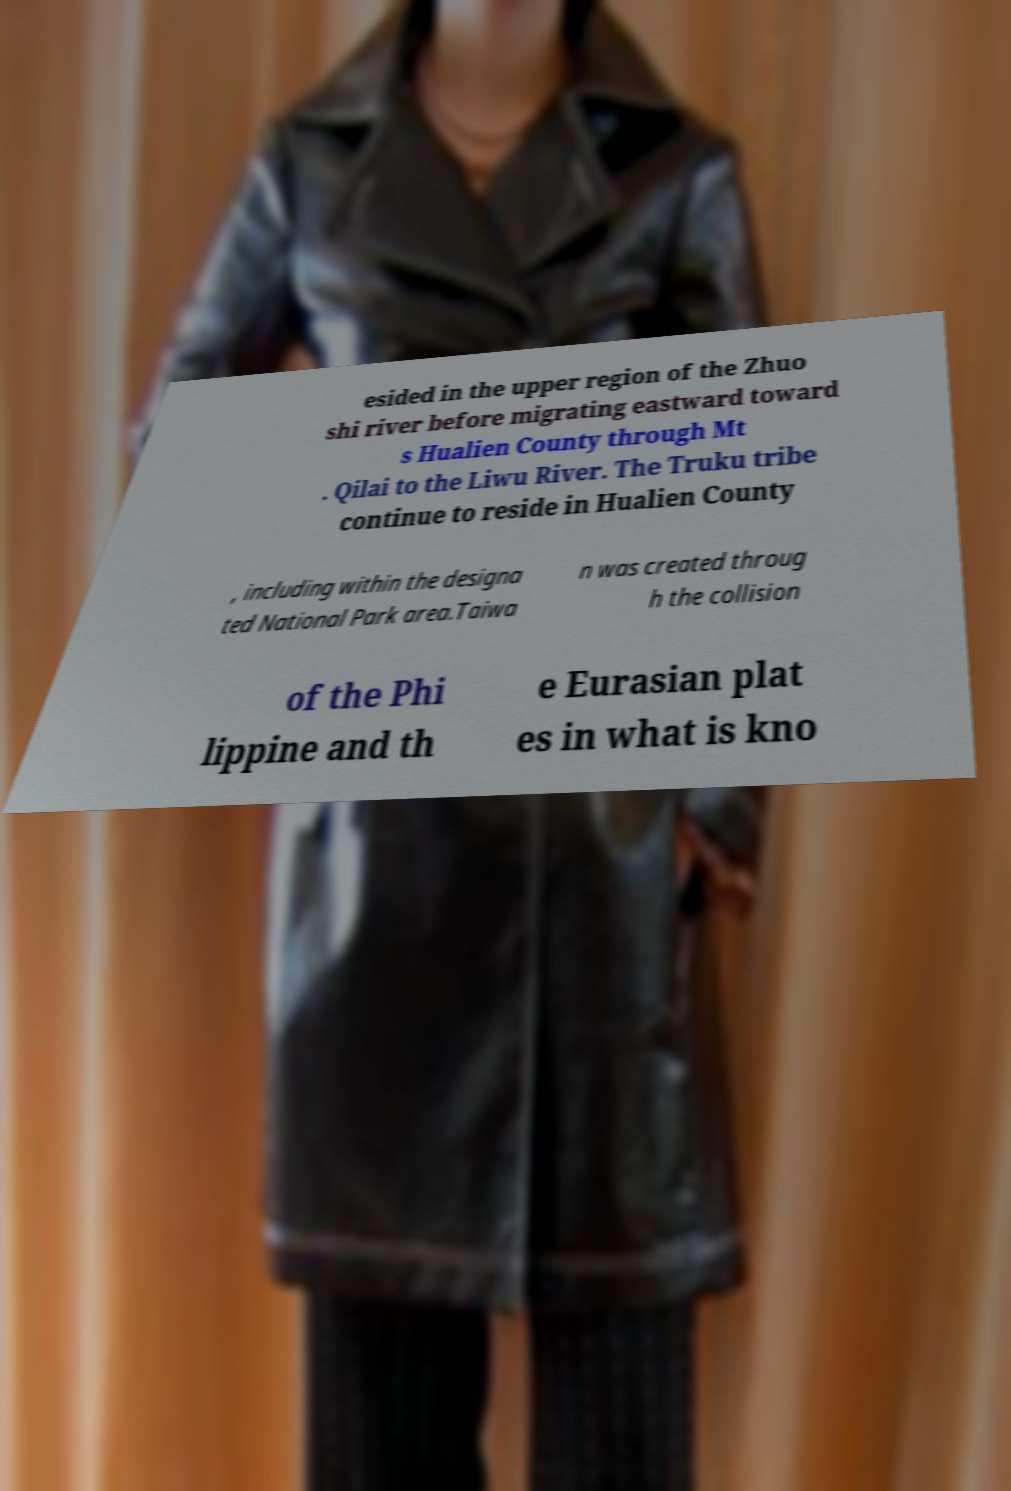What messages or text are displayed in this image? I need them in a readable, typed format. esided in the upper region of the Zhuo shi river before migrating eastward toward s Hualien County through Mt . Qilai to the Liwu River. The Truku tribe continue to reside in Hualien County , including within the designa ted National Park area.Taiwa n was created throug h the collision of the Phi lippine and th e Eurasian plat es in what is kno 